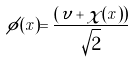<formula> <loc_0><loc_0><loc_500><loc_500>\phi ( x ) = \frac { \left ( \upsilon + \chi ( x ) \right ) } { \sqrt { 2 } }</formula> 